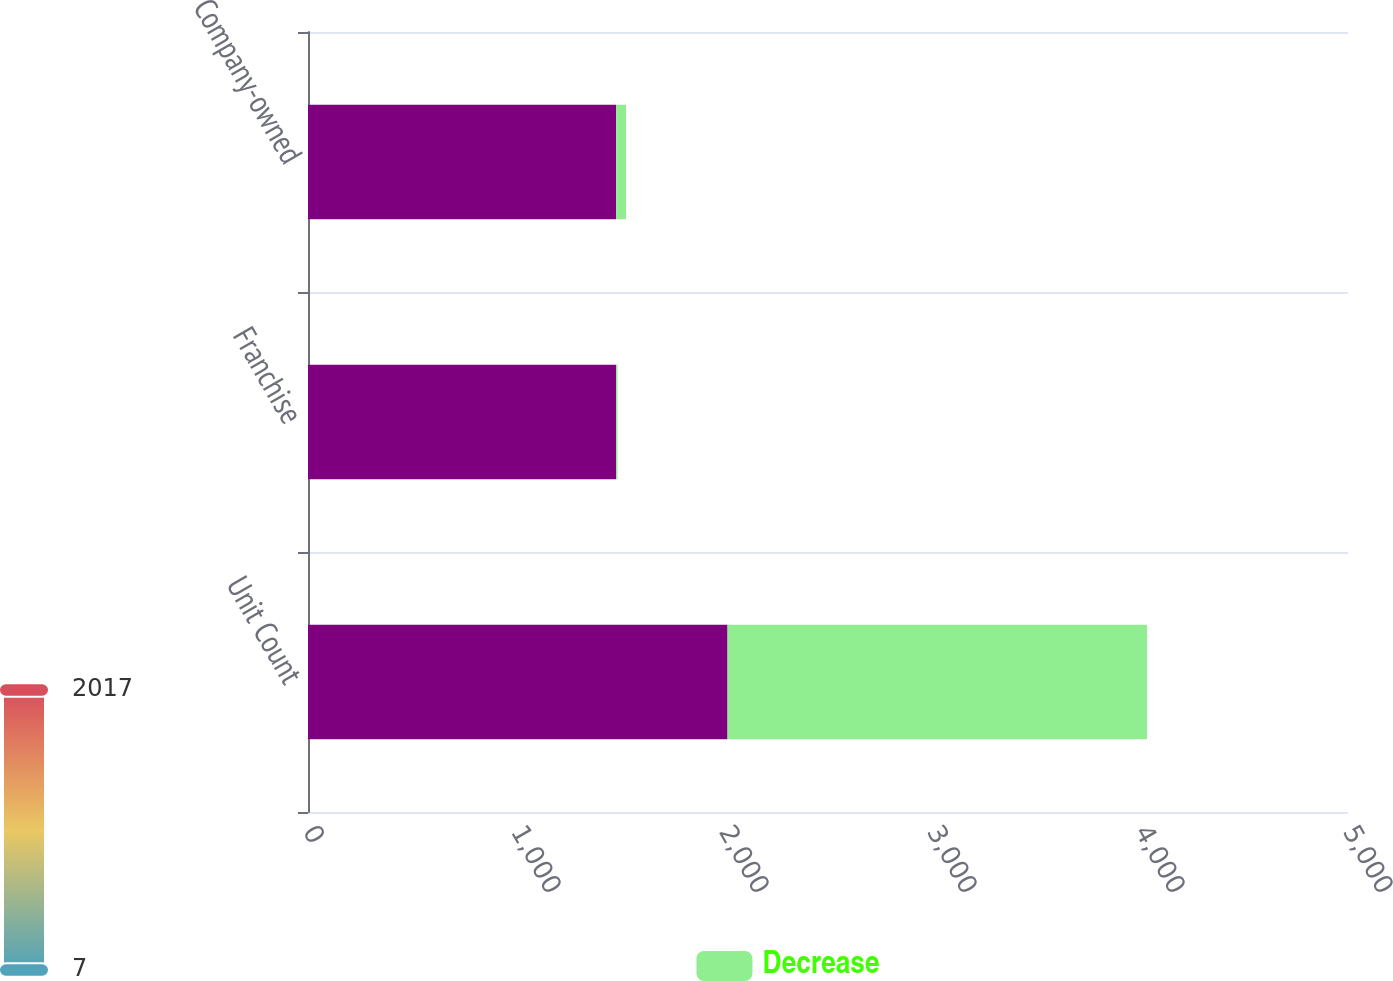Convert chart. <chart><loc_0><loc_0><loc_500><loc_500><stacked_bar_chart><ecel><fcel>Unit Count<fcel>Franchise<fcel>Company-owned<nl><fcel>nan<fcel>2017<fcel>1481<fcel>1481<nl><fcel>Decrease<fcel>2017<fcel>7<fcel>48<nl></chart> 